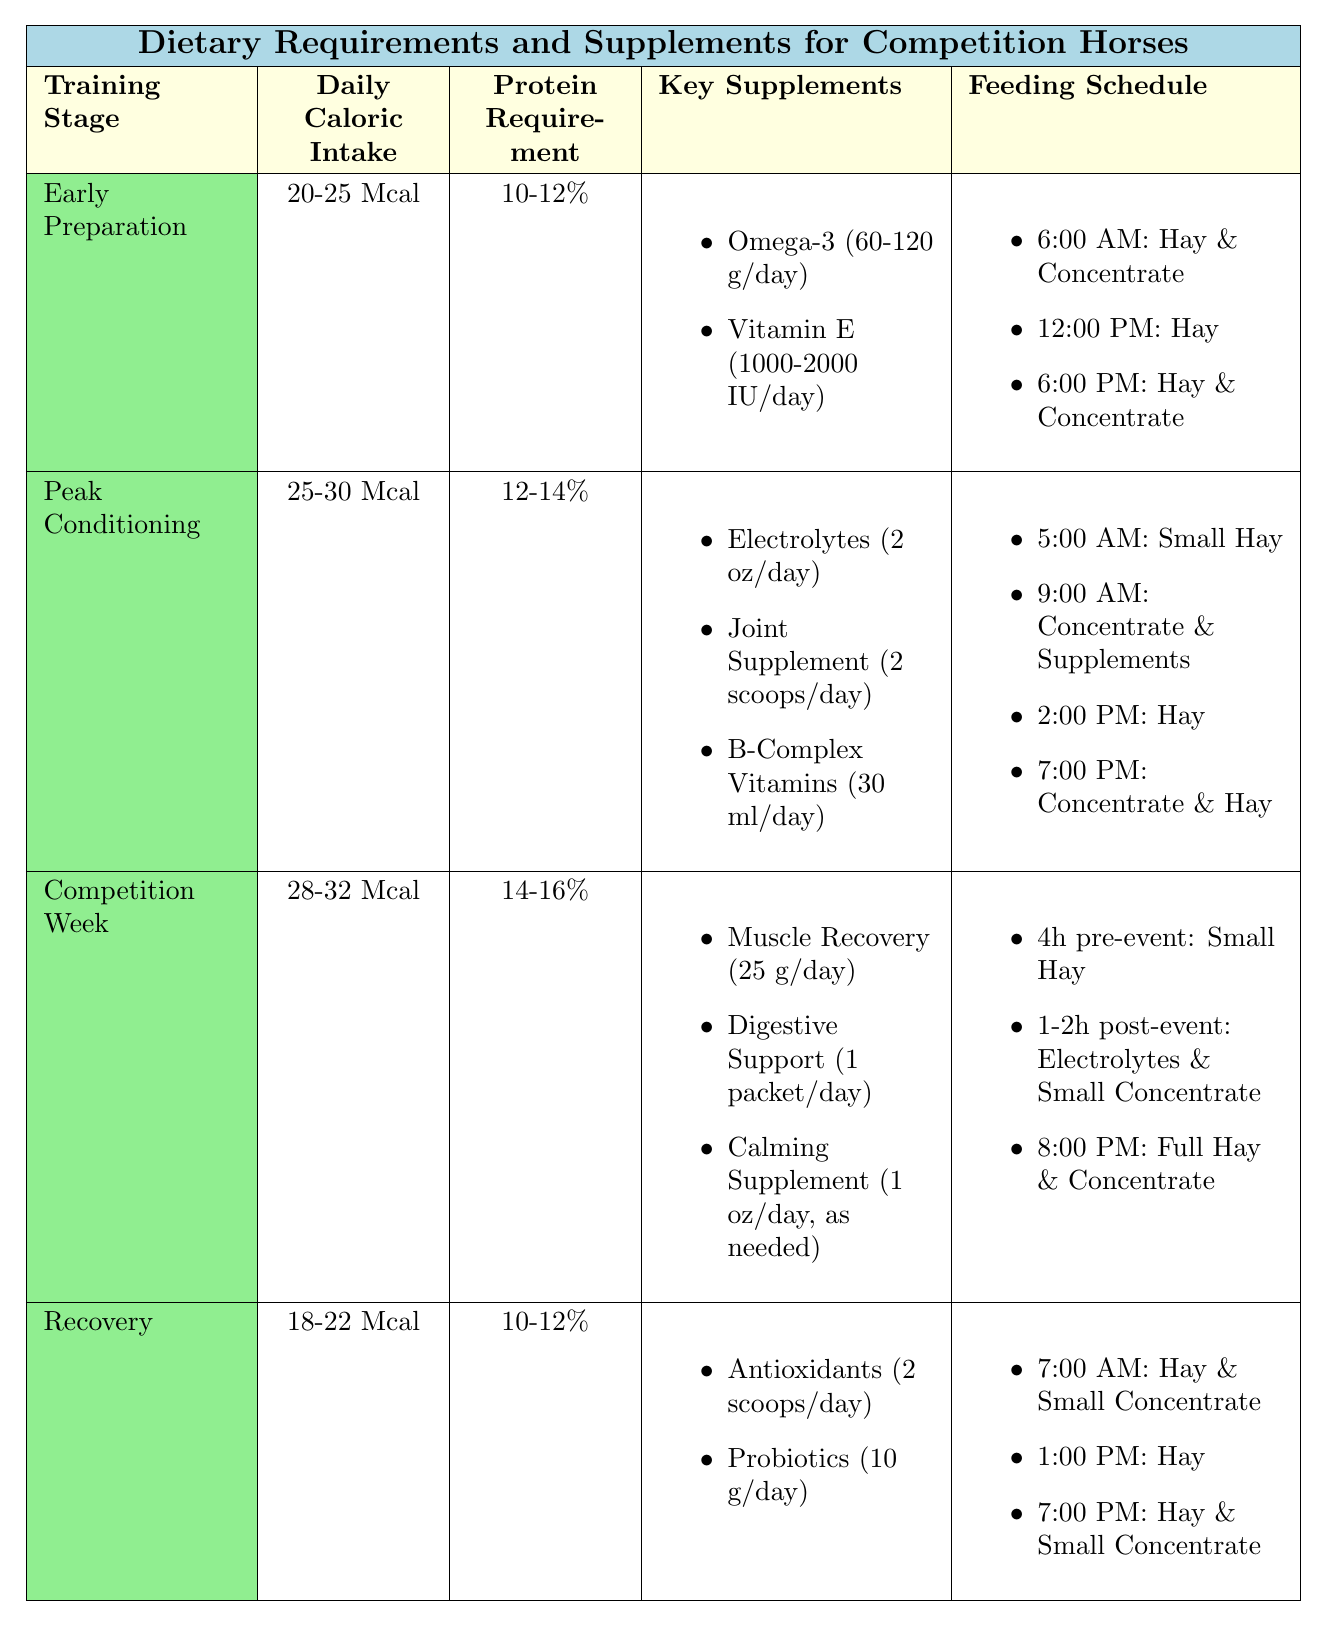What is the daily caloric intake during the Peak Conditioning stage? The table states that the daily caloric intake during the Peak Conditioning stage is between 25-30 Mcal.
Answer: 25-30 Mcal What supplement is required for Recovery, and what is its dosage? According to the table, Recovery requires Antioxidants at a dosage of 2 scoops/day and Probiotics at 10 g/day.
Answer: Antioxidants (2 scoops/day) and Probiotics (10 g/day) How many meals do horses have during the Competition Week, and what is the first meal? The table indicates that there are three meals during the Competition Week. The first meal is a small hay portion, served four hours before the event.
Answer: Three meals; first meal is small hay portion What is the protein requirement for horses in the Competition Week stage? The table shows that the protein requirement for horses during the Competition Week is 14-16%.
Answer: 14-16% What is the total number of supplements listed for the Peak Conditioning stage, and what is the dosage of the B-Complex Vitamins? The table lists three supplements for the Peak Conditioning stage, which are Electrolytes, Joint Supplement, and B-Complex Vitamins. The dosage for B-Complex Vitamins is 30 ml/day.
Answer: Three supplements; B-Complex Vitamins dosage is 30 ml/day During which training stage is the protein requirement the highest, and what is its percentage? The protein requirement is highest in the Competition Week stage at 14-16%.
Answer: Competition Week; 14-16% Calculate the average daily caloric intake for the Early Preparation stage and the Recovery stage. Early Preparation has an intake of 20-25 Mcal and Recovery has 18-22 Mcal. The average for Early Preparation is (20+25)/2 = 22.5 and for Recovery is (18+22)/2 = 20, thus the overall average is (22.5 + 20)/2 = 21.25.
Answer: 21.25 Mcal Is Vitamin E included as a supplement in the Recovery stage? Based on the data, Vitamin E is listed under the Early Preparation stage but not in the Recovery stage.
Answer: No What type of feeding schedule is provided for the Evening during the Recovery stage? The table specifies that during the Evening in the Recovery stage, horses are fed Hay and Small Concentrate Feed.
Answer: Hay and Small Concentrate Feed Which supplement is provided post-competition in the Competition Week, and what is its dosage? The table indicates that after the competition, horses are provided Electrolytes and a small concentrate feed; specifics on dosage are not defined for the concentrate but Electrolytes are provided in unspecified quantity.
Answer: Electrolytes and small concentrate feed (dosage unspecified) 